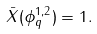Convert formula to latex. <formula><loc_0><loc_0><loc_500><loc_500>\bar { X } ( \phi ^ { 1 , 2 } _ { q } ) = 1 .</formula> 